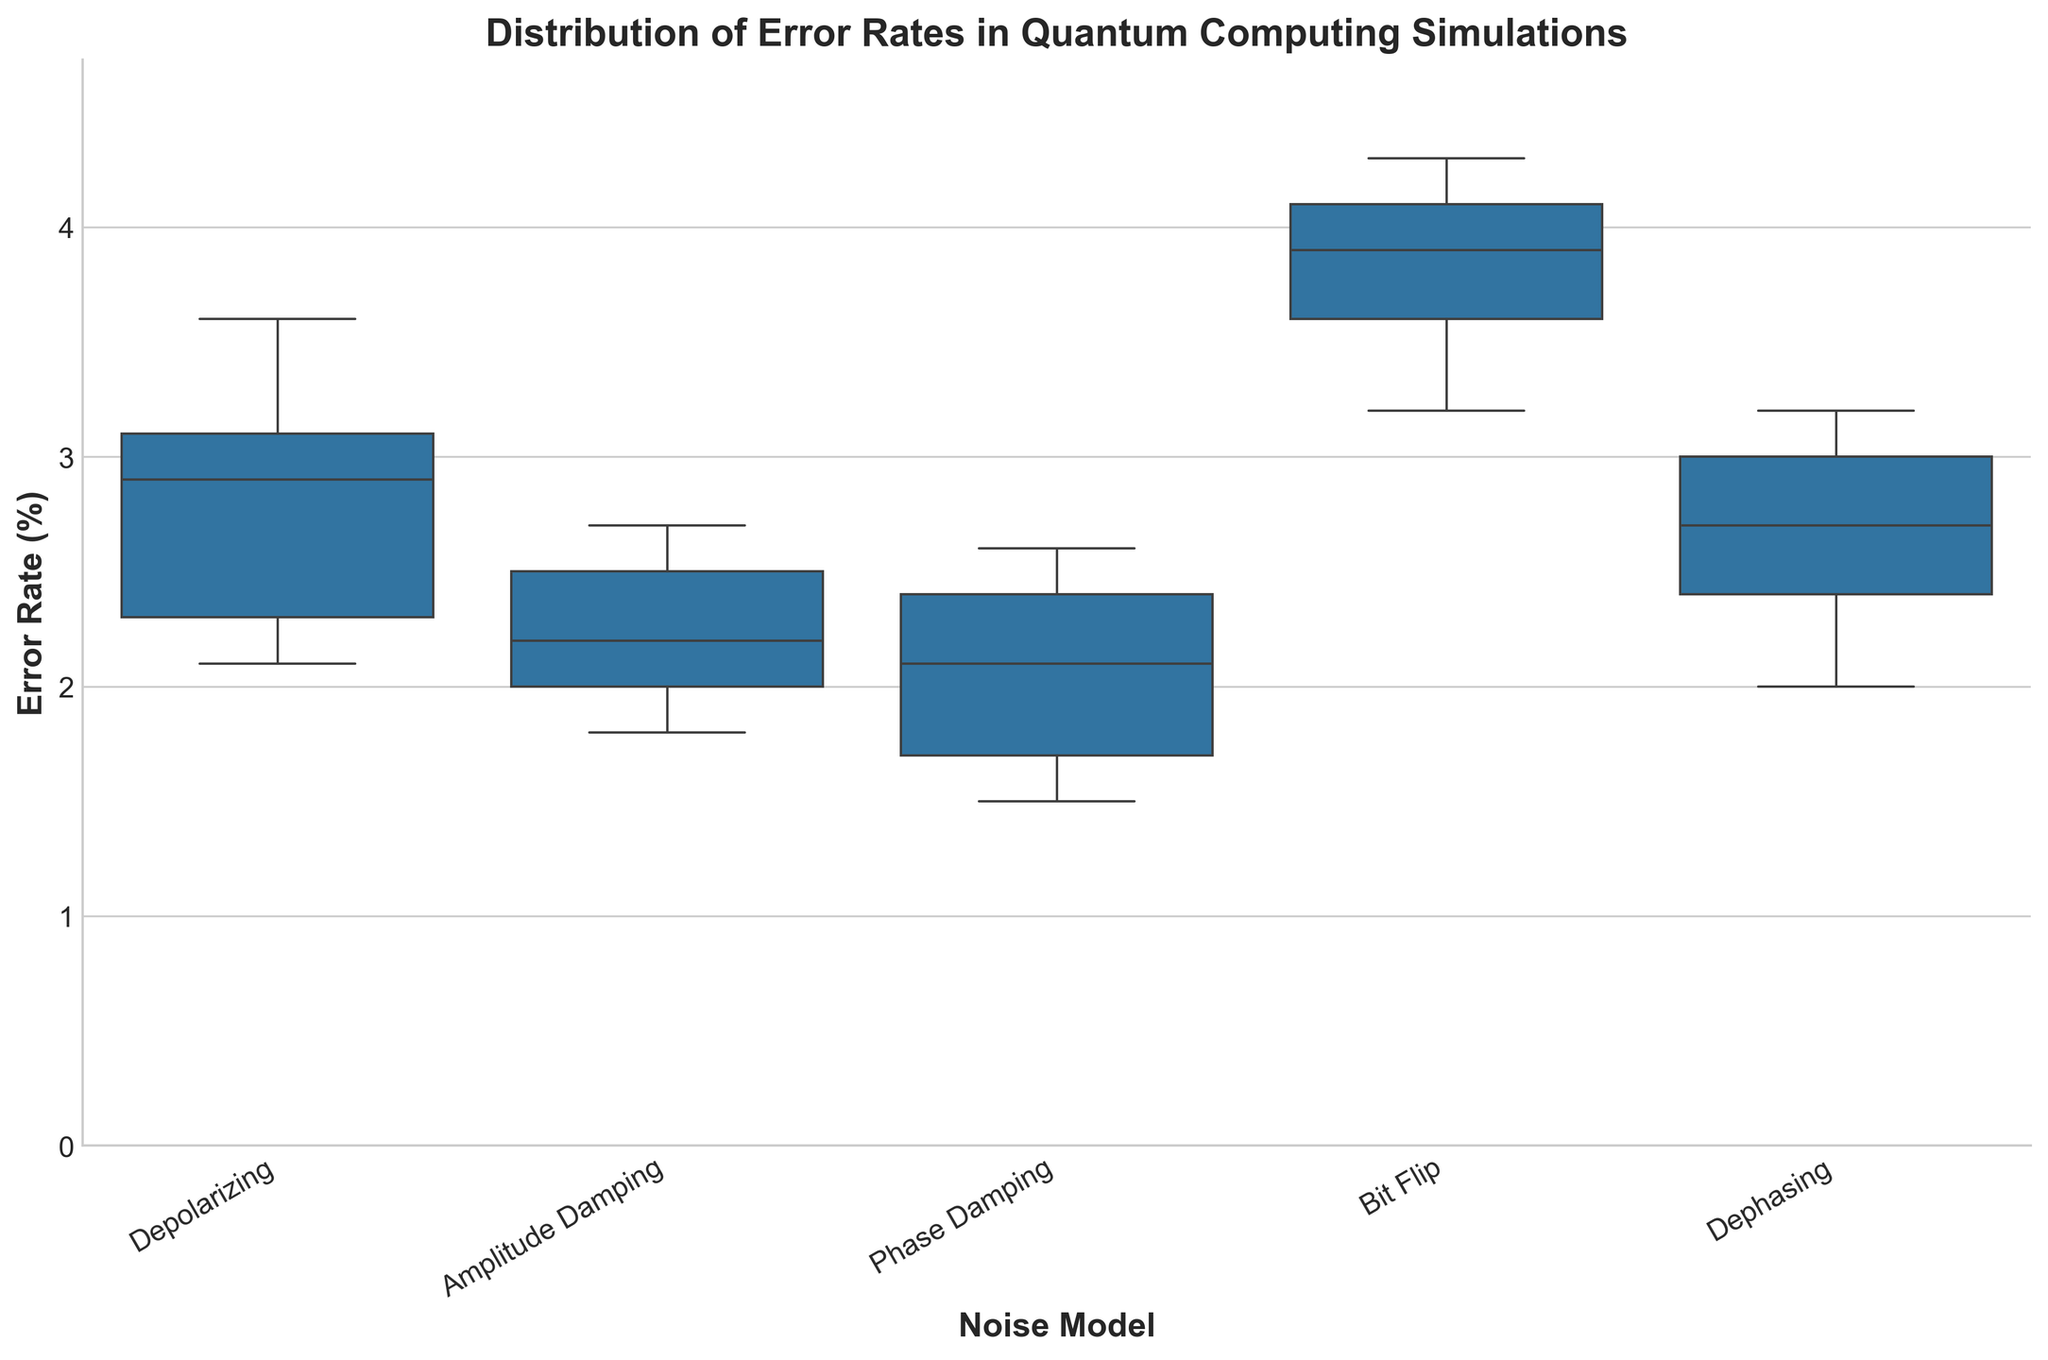How many noise models are presented in the figure? The x-axis lists distinct noise models, which can be counted directly.  There are five noise models: Depolarizing, Amplitude Damping, Phase Damping, Bit Flip, and Dephasing.
Answer: 5 What is the median error rate for the Depolarizing noise model? The median is represented by the line in the middle of the box for the Depolarizing box plot. From the visual estimate, it looks to be around 2.90%.
Answer: 2.90% Which noise model has the highest max error rate? The whisker extending to the maximum value needs to be observed for each noise model. The Bit Flip model has the highest upper whisker, around 4.3%.
Answer: Bit Flip What is the interquartile range (IQR) for the Error Rate in the Phase Damping noise model? The IQR is the range between the first quartile (Q1) and the third quartile (Q3). Visually estimate Q1 and Q3 from the box, which appear to be around 1.7% and 2.6% respectively. The IQR = Q3 - Q1, calculated as 2.6 - 1.7 = 0.9.
Answer: 0.9% Compare the median error rates of the Amplitude Damping and Bit Flip noise models. Which one is lower? The medians are the lines inside the boxes. Amplitude Damping's median is around 2.2%, while Bit Flip's median is around 3.9%. Therefore, Amplitude Damping's median is lower.
Answer: Amplitude Damping Which noise model shows the highest variability in error rates? Variability can be inferred from the length of the whiskers and the spread of the box. Bit Flip has a wide box and long whiskers indicating high variability.
Answer: Bit Flip What is the range of error rates for Depolarizing noise model? The range is the difference between the maximum and minimum values represented by the whiskers. For Depolarizing, the range is from around 2.1% to 3.6%, calculated as 3.6 - 2.1 = 1.5%.
Answer: 1.5% Is there a noise model where the 75th percentile (top edge of the box) is lower than the median of the Bit Flip model? The upper edge of the boxes for each noise model needs to be compared with the median line of the Bit Flip model. The top edge of the boxes for Depolarizing, Amplitude Damping, Phase Damping, and Dephasing are all lower than Bit Flip’s median.
Answer: Yes Do any of the noise models have overlapping interquartile ranges (boxes)? By inspecting the boxes, overlapping indicates that boxes overlap in the interquartile ranges. Depolarizing and Amplitude Damping; Phase Damping and Amplitude Damping have overlapping IQRs.
Answer: Yes Which noise model has the smallest minimum error rate? The minimum value is shown by the bottom whisker of each box plot. Phase Damping has the smallest minimum at 1.5%.
Answer: Phase Damping 